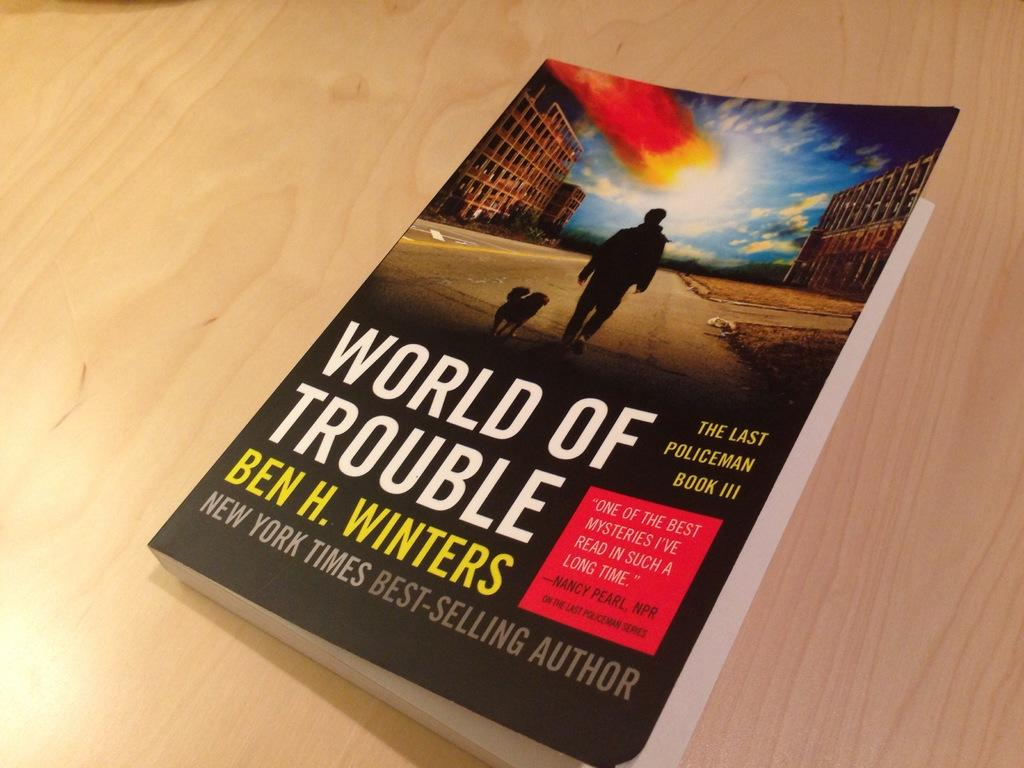<image>
Present a compact description of the photo's key features. Book called the World of Trouble lays on a wooden table. 